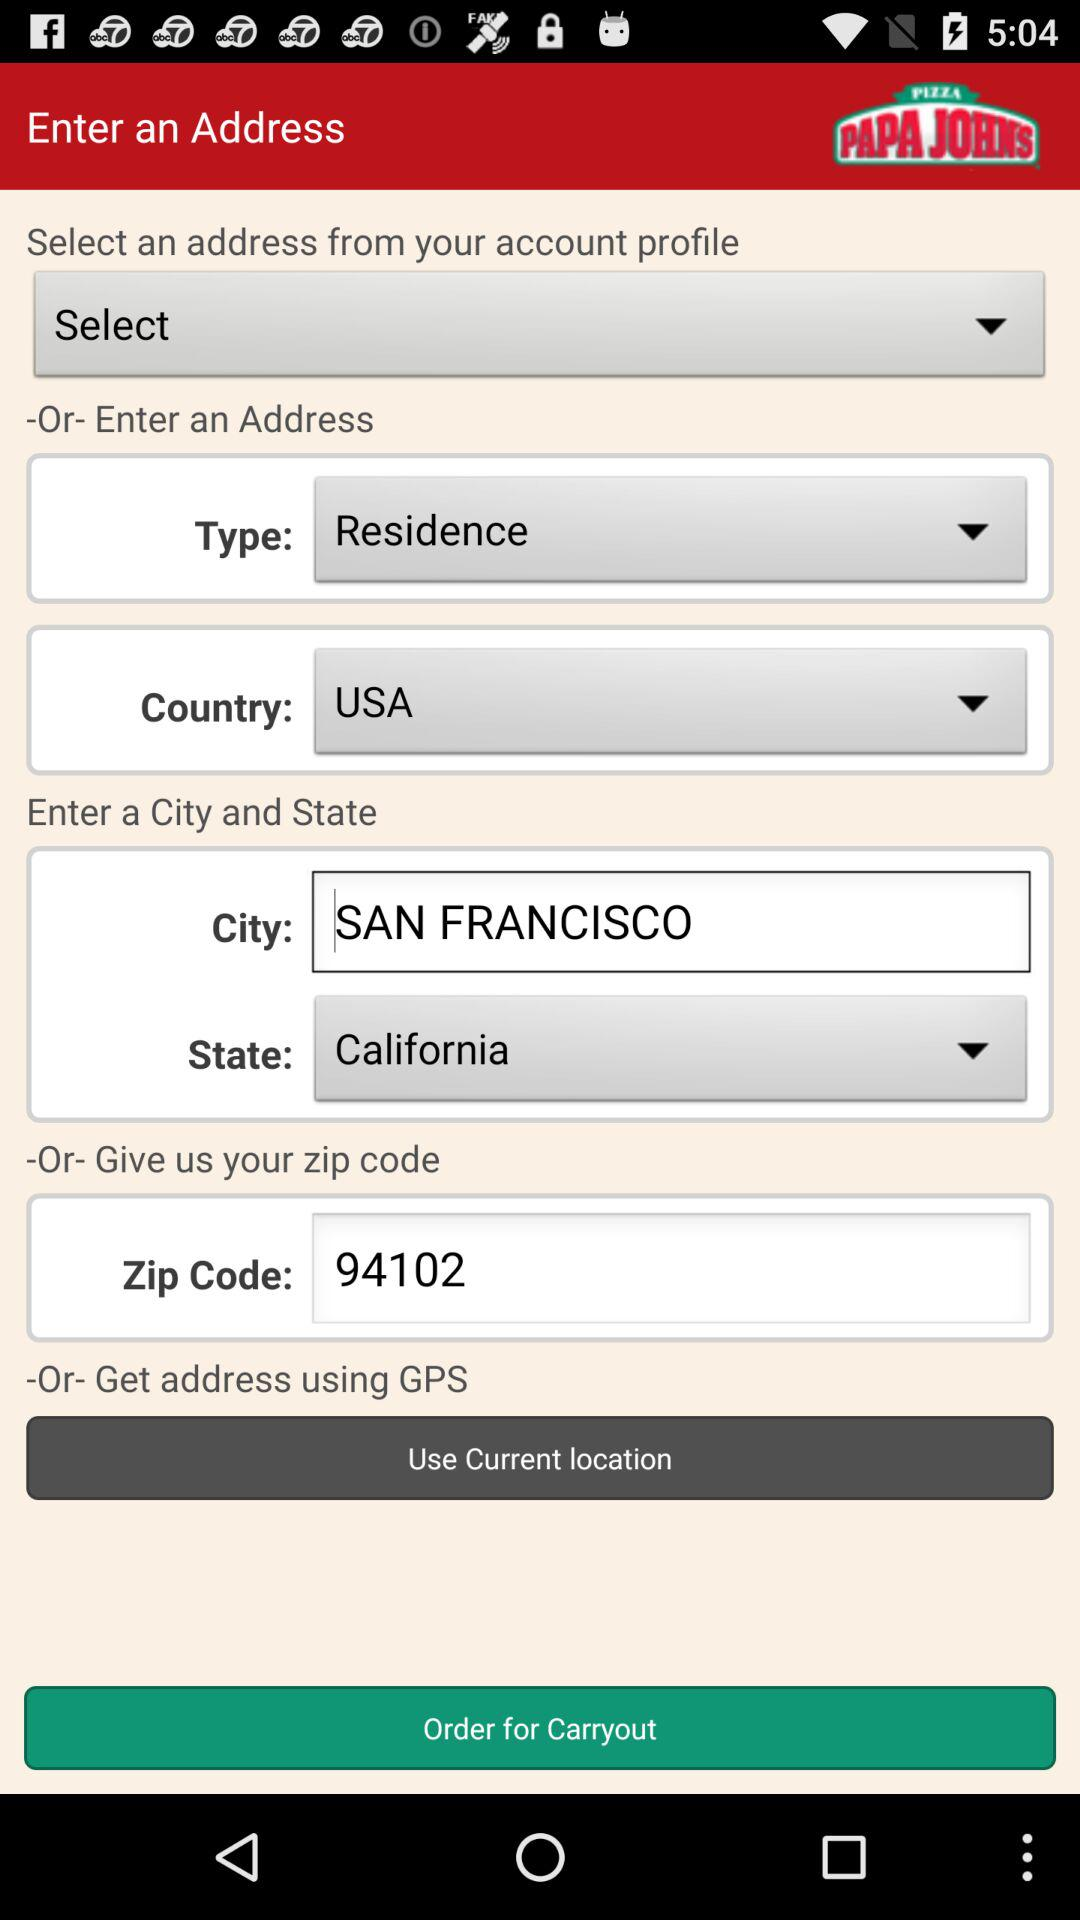What is the zip code of the city? The zip code of the city is 94102. 